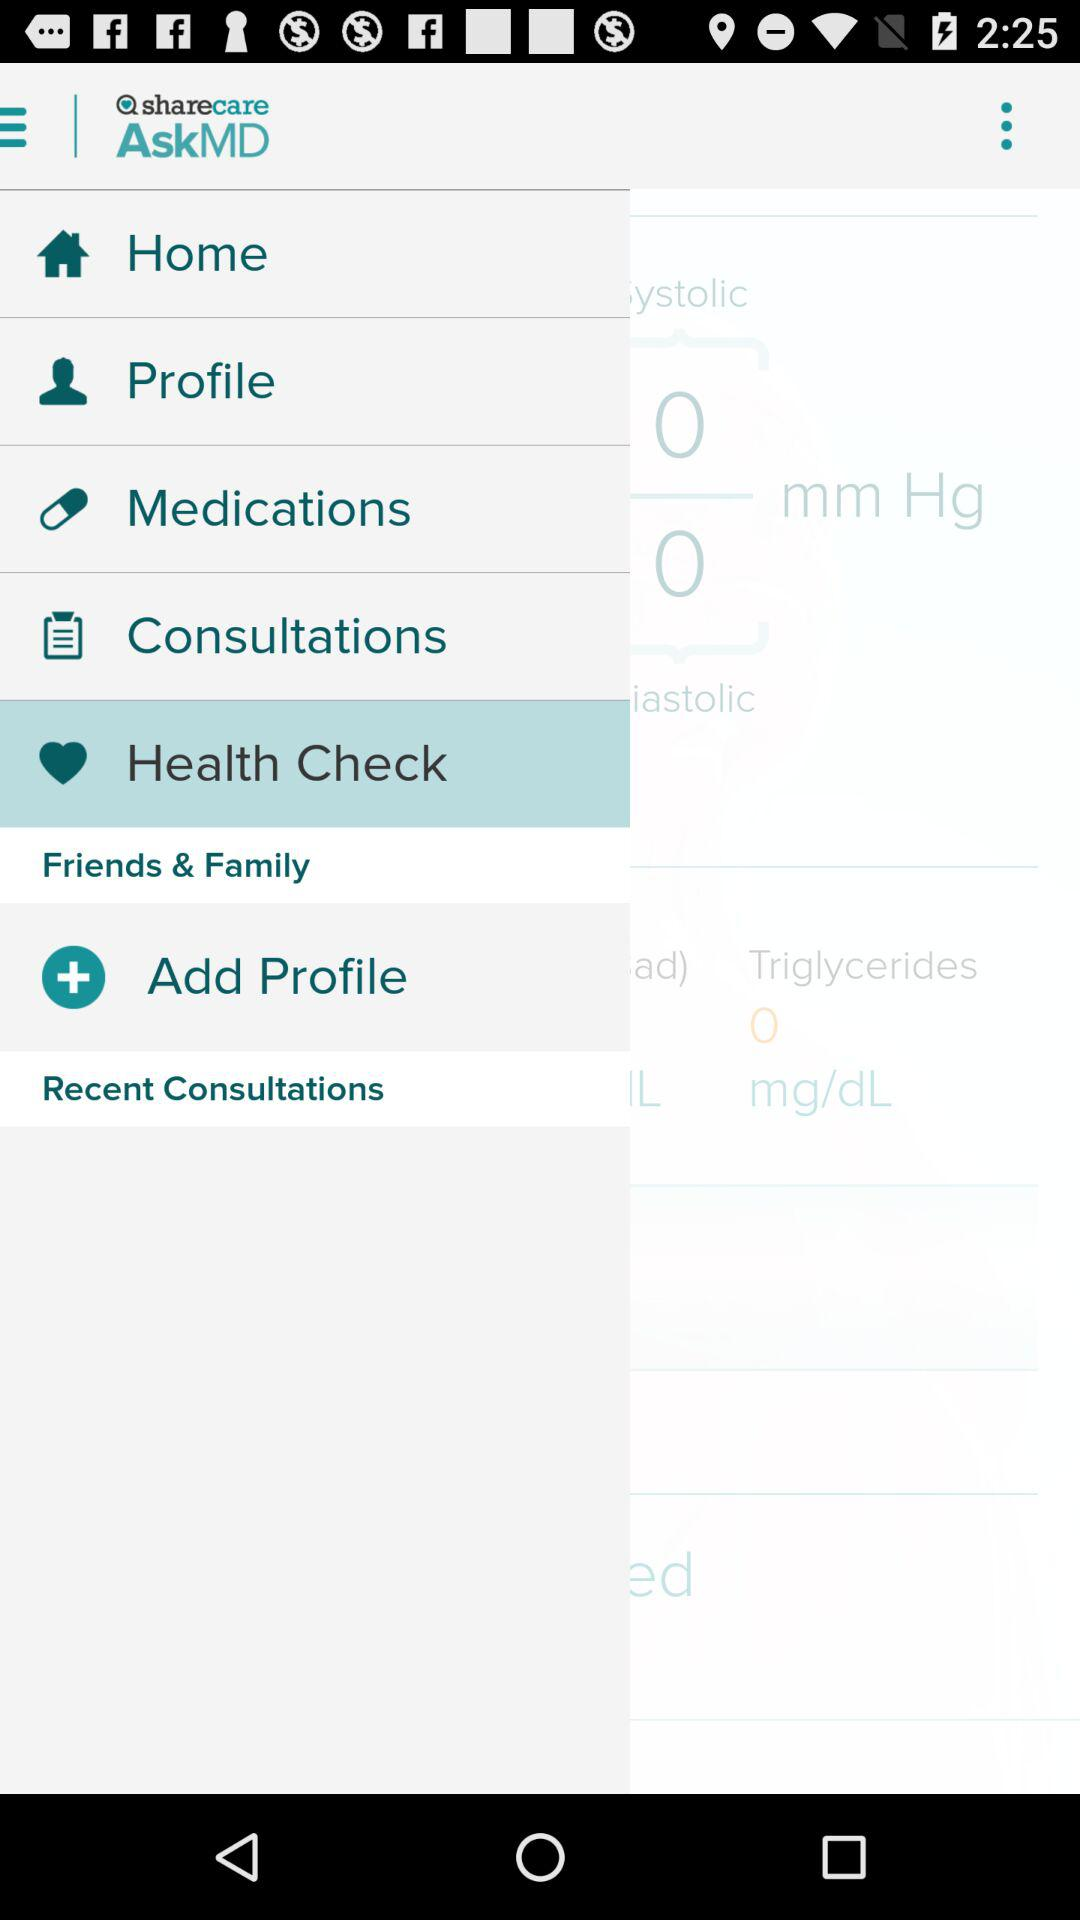What is the name of the application? The name of the application is "AskMD". 